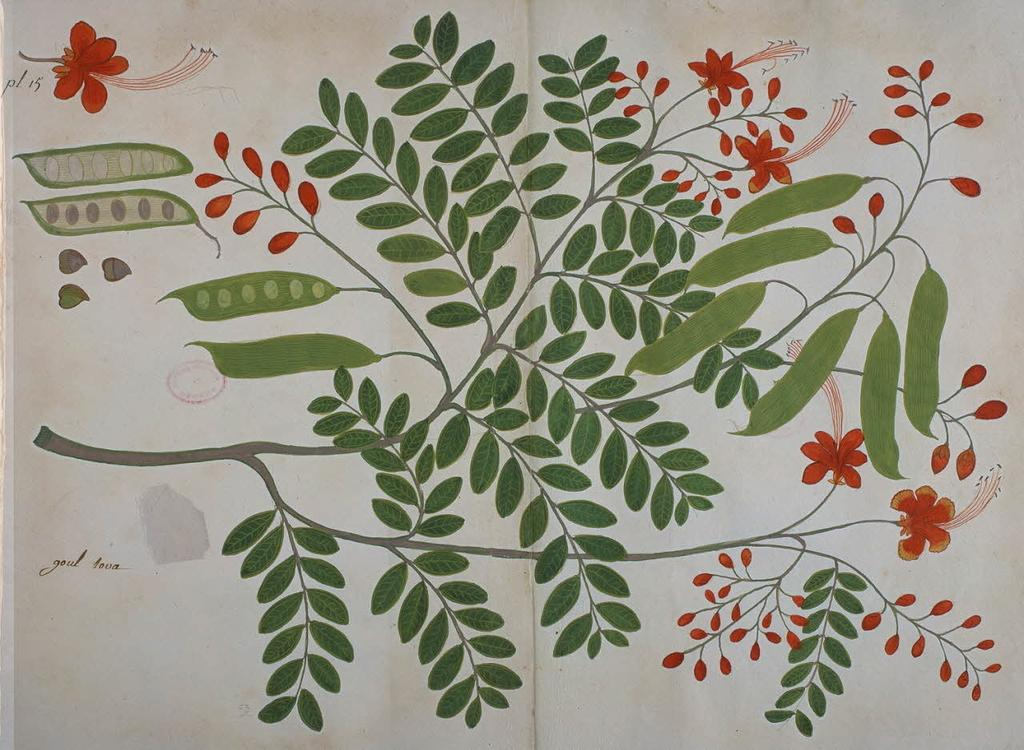What is present in the image that can be used for covering or decorating a window? There is a curtain in the image. What design elements are featured on the curtain? The curtain has printed leaves and flowers on it. Where can the steam be seen coming from in the image? There is no steam present in the image; it only features a curtain with printed leaves and flowers. 